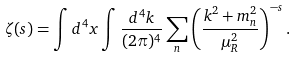<formula> <loc_0><loc_0><loc_500><loc_500>\zeta ( s ) = \int d ^ { 4 } x \int \frac { d ^ { 4 } k } { ( 2 \pi ) ^ { 4 } } \sum _ { n } \left ( \frac { k ^ { 2 } + m _ { n } ^ { 2 } } { \mu _ { R } ^ { 2 } } \right ) ^ { - s } .</formula> 